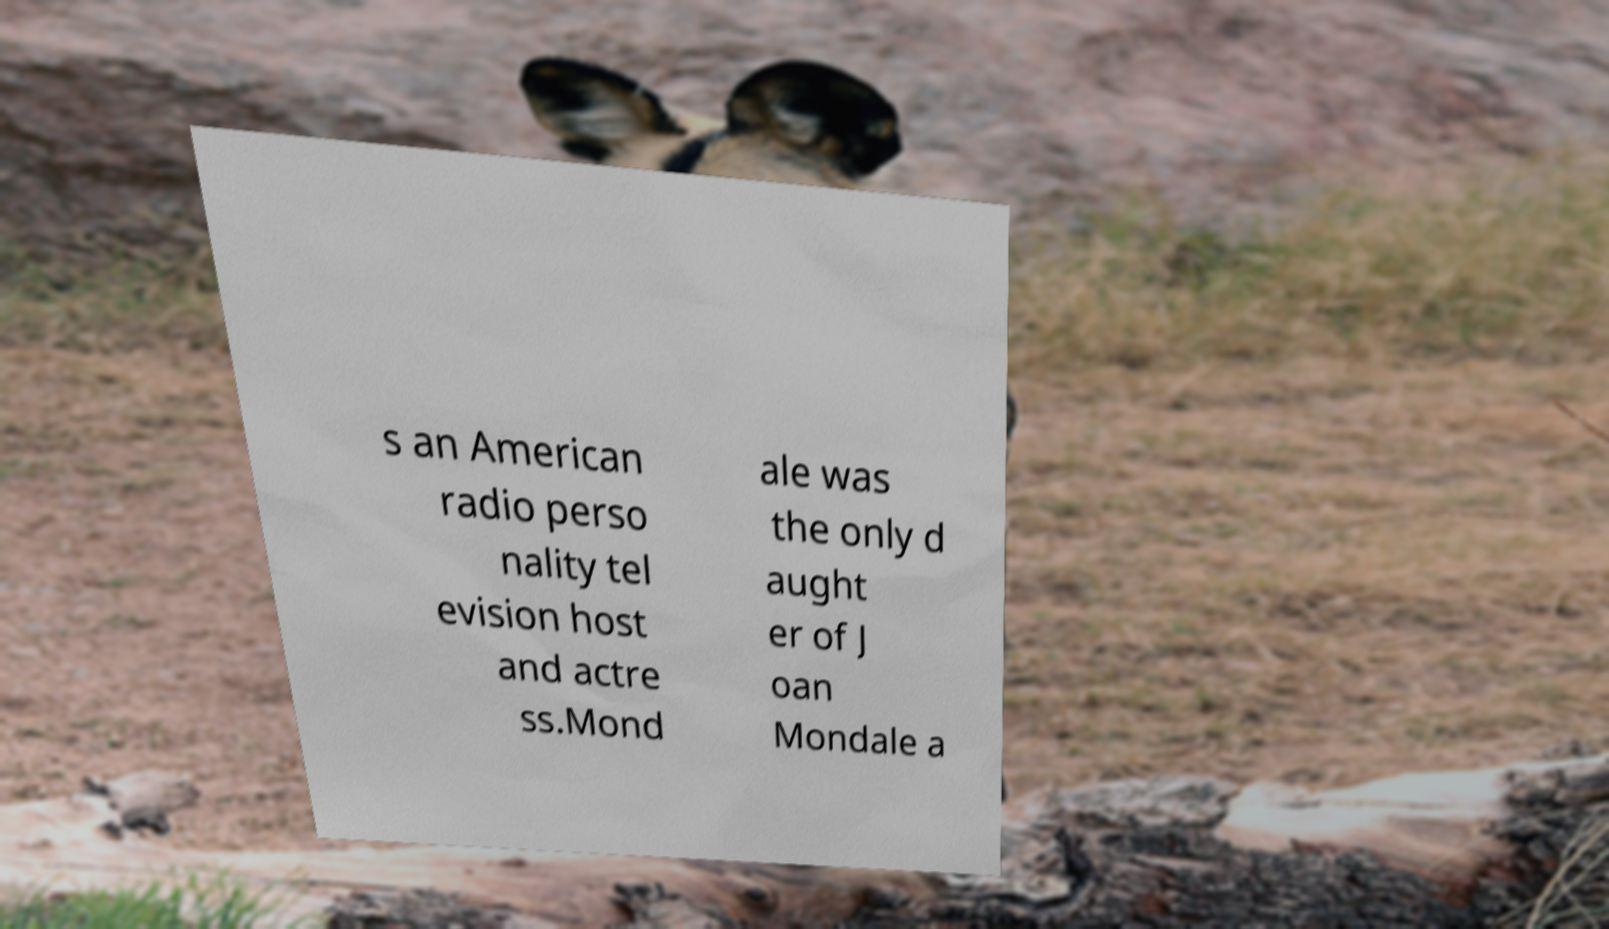I need the written content from this picture converted into text. Can you do that? s an American radio perso nality tel evision host and actre ss.Mond ale was the only d aught er of J oan Mondale a 